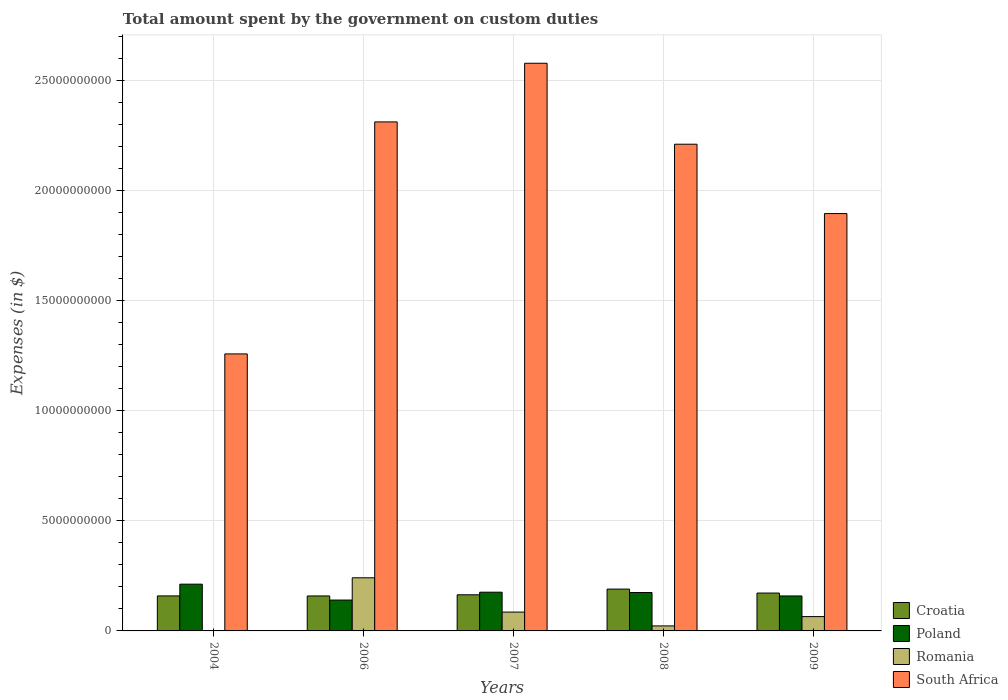How many different coloured bars are there?
Keep it short and to the point. 4. How many groups of bars are there?
Give a very brief answer. 5. Are the number of bars per tick equal to the number of legend labels?
Make the answer very short. Yes. Are the number of bars on each tick of the X-axis equal?
Give a very brief answer. Yes. How many bars are there on the 1st tick from the left?
Make the answer very short. 4. How many bars are there on the 2nd tick from the right?
Provide a short and direct response. 4. What is the amount spent on custom duties by the government in Poland in 2008?
Your answer should be compact. 1.74e+09. Across all years, what is the maximum amount spent on custom duties by the government in South Africa?
Give a very brief answer. 2.58e+1. Across all years, what is the minimum amount spent on custom duties by the government in Romania?
Provide a succinct answer. 7.91e+06. What is the total amount spent on custom duties by the government in Romania in the graph?
Your answer should be very brief. 4.16e+09. What is the difference between the amount spent on custom duties by the government in Romania in 2007 and that in 2009?
Provide a succinct answer. 2.05e+08. What is the difference between the amount spent on custom duties by the government in Romania in 2008 and the amount spent on custom duties by the government in Croatia in 2009?
Provide a succinct answer. -1.49e+09. What is the average amount spent on custom duties by the government in South Africa per year?
Keep it short and to the point. 2.05e+1. In the year 2006, what is the difference between the amount spent on custom duties by the government in Romania and amount spent on custom duties by the government in Croatia?
Make the answer very short. 8.26e+08. What is the ratio of the amount spent on custom duties by the government in South Africa in 2008 to that in 2009?
Offer a terse response. 1.17. What is the difference between the highest and the second highest amount spent on custom duties by the government in Poland?
Keep it short and to the point. 3.65e+08. What is the difference between the highest and the lowest amount spent on custom duties by the government in Poland?
Provide a succinct answer. 7.22e+08. In how many years, is the amount spent on custom duties by the government in Croatia greater than the average amount spent on custom duties by the government in Croatia taken over all years?
Provide a short and direct response. 2. Is the sum of the amount spent on custom duties by the government in Romania in 2006 and 2007 greater than the maximum amount spent on custom duties by the government in South Africa across all years?
Keep it short and to the point. No. Is it the case that in every year, the sum of the amount spent on custom duties by the government in Croatia and amount spent on custom duties by the government in South Africa is greater than the sum of amount spent on custom duties by the government in Poland and amount spent on custom duties by the government in Romania?
Provide a short and direct response. Yes. What does the 3rd bar from the left in 2009 represents?
Provide a short and direct response. Romania. What does the 3rd bar from the right in 2004 represents?
Offer a terse response. Poland. Is it the case that in every year, the sum of the amount spent on custom duties by the government in Romania and amount spent on custom duties by the government in Croatia is greater than the amount spent on custom duties by the government in South Africa?
Provide a short and direct response. No. How many bars are there?
Your response must be concise. 20. Are all the bars in the graph horizontal?
Make the answer very short. No. What is the difference between two consecutive major ticks on the Y-axis?
Your answer should be very brief. 5.00e+09. Does the graph contain any zero values?
Provide a short and direct response. No. Where does the legend appear in the graph?
Offer a terse response. Bottom right. How many legend labels are there?
Offer a terse response. 4. How are the legend labels stacked?
Keep it short and to the point. Vertical. What is the title of the graph?
Provide a short and direct response. Total amount spent by the government on custom duties. What is the label or title of the X-axis?
Offer a terse response. Years. What is the label or title of the Y-axis?
Keep it short and to the point. Expenses (in $). What is the Expenses (in $) in Croatia in 2004?
Your response must be concise. 1.59e+09. What is the Expenses (in $) of Poland in 2004?
Give a very brief answer. 2.12e+09. What is the Expenses (in $) in Romania in 2004?
Ensure brevity in your answer.  7.91e+06. What is the Expenses (in $) in South Africa in 2004?
Your answer should be very brief. 1.26e+1. What is the Expenses (in $) of Croatia in 2006?
Offer a terse response. 1.59e+09. What is the Expenses (in $) of Poland in 2006?
Your answer should be compact. 1.40e+09. What is the Expenses (in $) of Romania in 2006?
Ensure brevity in your answer.  2.41e+09. What is the Expenses (in $) in South Africa in 2006?
Keep it short and to the point. 2.31e+1. What is the Expenses (in $) of Croatia in 2007?
Keep it short and to the point. 1.64e+09. What is the Expenses (in $) of Poland in 2007?
Offer a very short reply. 1.76e+09. What is the Expenses (in $) in Romania in 2007?
Keep it short and to the point. 8.56e+08. What is the Expenses (in $) of South Africa in 2007?
Provide a short and direct response. 2.58e+1. What is the Expenses (in $) in Croatia in 2008?
Your response must be concise. 1.90e+09. What is the Expenses (in $) in Poland in 2008?
Make the answer very short. 1.74e+09. What is the Expenses (in $) in Romania in 2008?
Give a very brief answer. 2.28e+08. What is the Expenses (in $) in South Africa in 2008?
Make the answer very short. 2.21e+1. What is the Expenses (in $) of Croatia in 2009?
Provide a succinct answer. 1.72e+09. What is the Expenses (in $) in Poland in 2009?
Provide a short and direct response. 1.59e+09. What is the Expenses (in $) in Romania in 2009?
Your answer should be compact. 6.50e+08. What is the Expenses (in $) in South Africa in 2009?
Provide a succinct answer. 1.90e+1. Across all years, what is the maximum Expenses (in $) of Croatia?
Make the answer very short. 1.90e+09. Across all years, what is the maximum Expenses (in $) in Poland?
Provide a short and direct response. 2.12e+09. Across all years, what is the maximum Expenses (in $) of Romania?
Provide a short and direct response. 2.41e+09. Across all years, what is the maximum Expenses (in $) of South Africa?
Your response must be concise. 2.58e+1. Across all years, what is the minimum Expenses (in $) of Croatia?
Your answer should be very brief. 1.59e+09. Across all years, what is the minimum Expenses (in $) of Poland?
Your answer should be very brief. 1.40e+09. Across all years, what is the minimum Expenses (in $) of Romania?
Your response must be concise. 7.91e+06. Across all years, what is the minimum Expenses (in $) in South Africa?
Your answer should be very brief. 1.26e+1. What is the total Expenses (in $) of Croatia in the graph?
Your answer should be very brief. 8.44e+09. What is the total Expenses (in $) of Poland in the graph?
Ensure brevity in your answer.  8.62e+09. What is the total Expenses (in $) of Romania in the graph?
Give a very brief answer. 4.16e+09. What is the total Expenses (in $) in South Africa in the graph?
Keep it short and to the point. 1.03e+11. What is the difference between the Expenses (in $) of Croatia in 2004 and that in 2006?
Your answer should be very brief. 1.70e+06. What is the difference between the Expenses (in $) in Poland in 2004 and that in 2006?
Your response must be concise. 7.22e+08. What is the difference between the Expenses (in $) of Romania in 2004 and that in 2006?
Provide a short and direct response. -2.41e+09. What is the difference between the Expenses (in $) of South Africa in 2004 and that in 2006?
Your response must be concise. -1.05e+1. What is the difference between the Expenses (in $) in Croatia in 2004 and that in 2007?
Make the answer very short. -5.13e+07. What is the difference between the Expenses (in $) of Poland in 2004 and that in 2007?
Your answer should be compact. 3.65e+08. What is the difference between the Expenses (in $) of Romania in 2004 and that in 2007?
Offer a very short reply. -8.48e+08. What is the difference between the Expenses (in $) in South Africa in 2004 and that in 2007?
Keep it short and to the point. -1.32e+1. What is the difference between the Expenses (in $) in Croatia in 2004 and that in 2008?
Provide a short and direct response. -3.10e+08. What is the difference between the Expenses (in $) of Poland in 2004 and that in 2008?
Your answer should be very brief. 3.80e+08. What is the difference between the Expenses (in $) of Romania in 2004 and that in 2008?
Your answer should be compact. -2.20e+08. What is the difference between the Expenses (in $) in South Africa in 2004 and that in 2008?
Give a very brief answer. -9.53e+09. What is the difference between the Expenses (in $) of Croatia in 2004 and that in 2009?
Keep it short and to the point. -1.30e+08. What is the difference between the Expenses (in $) in Poland in 2004 and that in 2009?
Give a very brief answer. 5.36e+08. What is the difference between the Expenses (in $) in Romania in 2004 and that in 2009?
Your answer should be very brief. -6.43e+08. What is the difference between the Expenses (in $) in South Africa in 2004 and that in 2009?
Keep it short and to the point. -6.38e+09. What is the difference between the Expenses (in $) in Croatia in 2006 and that in 2007?
Provide a short and direct response. -5.30e+07. What is the difference between the Expenses (in $) of Poland in 2006 and that in 2007?
Offer a very short reply. -3.57e+08. What is the difference between the Expenses (in $) of Romania in 2006 and that in 2007?
Keep it short and to the point. 1.56e+09. What is the difference between the Expenses (in $) of South Africa in 2006 and that in 2007?
Provide a succinct answer. -2.67e+09. What is the difference between the Expenses (in $) of Croatia in 2006 and that in 2008?
Keep it short and to the point. -3.12e+08. What is the difference between the Expenses (in $) in Poland in 2006 and that in 2008?
Offer a very short reply. -3.42e+08. What is the difference between the Expenses (in $) of Romania in 2006 and that in 2008?
Offer a terse response. 2.19e+09. What is the difference between the Expenses (in $) of South Africa in 2006 and that in 2008?
Give a very brief answer. 1.01e+09. What is the difference between the Expenses (in $) in Croatia in 2006 and that in 2009?
Your answer should be compact. -1.32e+08. What is the difference between the Expenses (in $) in Poland in 2006 and that in 2009?
Your answer should be very brief. -1.86e+08. What is the difference between the Expenses (in $) in Romania in 2006 and that in 2009?
Your answer should be compact. 1.76e+09. What is the difference between the Expenses (in $) in South Africa in 2006 and that in 2009?
Your response must be concise. 4.16e+09. What is the difference between the Expenses (in $) of Croatia in 2007 and that in 2008?
Offer a very short reply. -2.59e+08. What is the difference between the Expenses (in $) in Poland in 2007 and that in 2008?
Your answer should be very brief. 1.50e+07. What is the difference between the Expenses (in $) of Romania in 2007 and that in 2008?
Keep it short and to the point. 6.28e+08. What is the difference between the Expenses (in $) in South Africa in 2007 and that in 2008?
Provide a short and direct response. 3.68e+09. What is the difference between the Expenses (in $) in Croatia in 2007 and that in 2009?
Your response must be concise. -7.92e+07. What is the difference between the Expenses (in $) of Poland in 2007 and that in 2009?
Provide a succinct answer. 1.71e+08. What is the difference between the Expenses (in $) in Romania in 2007 and that in 2009?
Offer a terse response. 2.05e+08. What is the difference between the Expenses (in $) of South Africa in 2007 and that in 2009?
Offer a terse response. 6.83e+09. What is the difference between the Expenses (in $) of Croatia in 2008 and that in 2009?
Your answer should be very brief. 1.80e+08. What is the difference between the Expenses (in $) of Poland in 2008 and that in 2009?
Offer a very short reply. 1.56e+08. What is the difference between the Expenses (in $) in Romania in 2008 and that in 2009?
Your response must be concise. -4.23e+08. What is the difference between the Expenses (in $) of South Africa in 2008 and that in 2009?
Offer a terse response. 3.15e+09. What is the difference between the Expenses (in $) of Croatia in 2004 and the Expenses (in $) of Poland in 2006?
Make the answer very short. 1.88e+08. What is the difference between the Expenses (in $) in Croatia in 2004 and the Expenses (in $) in Romania in 2006?
Provide a succinct answer. -8.24e+08. What is the difference between the Expenses (in $) of Croatia in 2004 and the Expenses (in $) of South Africa in 2006?
Ensure brevity in your answer.  -2.15e+1. What is the difference between the Expenses (in $) of Poland in 2004 and the Expenses (in $) of Romania in 2006?
Your response must be concise. -2.90e+08. What is the difference between the Expenses (in $) in Poland in 2004 and the Expenses (in $) in South Africa in 2006?
Ensure brevity in your answer.  -2.10e+1. What is the difference between the Expenses (in $) of Romania in 2004 and the Expenses (in $) of South Africa in 2006?
Offer a very short reply. -2.31e+1. What is the difference between the Expenses (in $) of Croatia in 2004 and the Expenses (in $) of Poland in 2007?
Your answer should be very brief. -1.69e+08. What is the difference between the Expenses (in $) in Croatia in 2004 and the Expenses (in $) in Romania in 2007?
Offer a very short reply. 7.35e+08. What is the difference between the Expenses (in $) in Croatia in 2004 and the Expenses (in $) in South Africa in 2007?
Your answer should be compact. -2.42e+1. What is the difference between the Expenses (in $) of Poland in 2004 and the Expenses (in $) of Romania in 2007?
Make the answer very short. 1.27e+09. What is the difference between the Expenses (in $) in Poland in 2004 and the Expenses (in $) in South Africa in 2007?
Keep it short and to the point. -2.37e+1. What is the difference between the Expenses (in $) in Romania in 2004 and the Expenses (in $) in South Africa in 2007?
Make the answer very short. -2.58e+1. What is the difference between the Expenses (in $) in Croatia in 2004 and the Expenses (in $) in Poland in 2008?
Ensure brevity in your answer.  -1.54e+08. What is the difference between the Expenses (in $) of Croatia in 2004 and the Expenses (in $) of Romania in 2008?
Offer a very short reply. 1.36e+09. What is the difference between the Expenses (in $) of Croatia in 2004 and the Expenses (in $) of South Africa in 2008?
Your answer should be compact. -2.05e+1. What is the difference between the Expenses (in $) in Poland in 2004 and the Expenses (in $) in Romania in 2008?
Give a very brief answer. 1.90e+09. What is the difference between the Expenses (in $) in Poland in 2004 and the Expenses (in $) in South Africa in 2008?
Make the answer very short. -2.00e+1. What is the difference between the Expenses (in $) in Romania in 2004 and the Expenses (in $) in South Africa in 2008?
Offer a very short reply. -2.21e+1. What is the difference between the Expenses (in $) in Croatia in 2004 and the Expenses (in $) in Poland in 2009?
Provide a succinct answer. 1.70e+06. What is the difference between the Expenses (in $) in Croatia in 2004 and the Expenses (in $) in Romania in 2009?
Give a very brief answer. 9.40e+08. What is the difference between the Expenses (in $) in Croatia in 2004 and the Expenses (in $) in South Africa in 2009?
Give a very brief answer. -1.74e+1. What is the difference between the Expenses (in $) of Poland in 2004 and the Expenses (in $) of Romania in 2009?
Ensure brevity in your answer.  1.47e+09. What is the difference between the Expenses (in $) in Poland in 2004 and the Expenses (in $) in South Africa in 2009?
Your answer should be compact. -1.68e+1. What is the difference between the Expenses (in $) in Romania in 2004 and the Expenses (in $) in South Africa in 2009?
Offer a very short reply. -1.90e+1. What is the difference between the Expenses (in $) of Croatia in 2006 and the Expenses (in $) of Poland in 2007?
Provide a short and direct response. -1.71e+08. What is the difference between the Expenses (in $) in Croatia in 2006 and the Expenses (in $) in Romania in 2007?
Make the answer very short. 7.33e+08. What is the difference between the Expenses (in $) of Croatia in 2006 and the Expenses (in $) of South Africa in 2007?
Your answer should be compact. -2.42e+1. What is the difference between the Expenses (in $) in Poland in 2006 and the Expenses (in $) in Romania in 2007?
Your answer should be compact. 5.47e+08. What is the difference between the Expenses (in $) of Poland in 2006 and the Expenses (in $) of South Africa in 2007?
Your answer should be very brief. -2.44e+1. What is the difference between the Expenses (in $) of Romania in 2006 and the Expenses (in $) of South Africa in 2007?
Offer a very short reply. -2.34e+1. What is the difference between the Expenses (in $) of Croatia in 2006 and the Expenses (in $) of Poland in 2008?
Offer a terse response. -1.56e+08. What is the difference between the Expenses (in $) in Croatia in 2006 and the Expenses (in $) in Romania in 2008?
Provide a succinct answer. 1.36e+09. What is the difference between the Expenses (in $) of Croatia in 2006 and the Expenses (in $) of South Africa in 2008?
Make the answer very short. -2.05e+1. What is the difference between the Expenses (in $) in Poland in 2006 and the Expenses (in $) in Romania in 2008?
Provide a succinct answer. 1.18e+09. What is the difference between the Expenses (in $) in Poland in 2006 and the Expenses (in $) in South Africa in 2008?
Offer a terse response. -2.07e+1. What is the difference between the Expenses (in $) of Romania in 2006 and the Expenses (in $) of South Africa in 2008?
Your answer should be compact. -1.97e+1. What is the difference between the Expenses (in $) of Croatia in 2006 and the Expenses (in $) of Romania in 2009?
Your response must be concise. 9.39e+08. What is the difference between the Expenses (in $) in Croatia in 2006 and the Expenses (in $) in South Africa in 2009?
Give a very brief answer. -1.74e+1. What is the difference between the Expenses (in $) in Poland in 2006 and the Expenses (in $) in Romania in 2009?
Make the answer very short. 7.53e+08. What is the difference between the Expenses (in $) of Poland in 2006 and the Expenses (in $) of South Africa in 2009?
Give a very brief answer. -1.76e+1. What is the difference between the Expenses (in $) in Romania in 2006 and the Expenses (in $) in South Africa in 2009?
Your answer should be compact. -1.66e+1. What is the difference between the Expenses (in $) of Croatia in 2007 and the Expenses (in $) of Poland in 2008?
Provide a short and direct response. -1.03e+08. What is the difference between the Expenses (in $) of Croatia in 2007 and the Expenses (in $) of Romania in 2008?
Keep it short and to the point. 1.41e+09. What is the difference between the Expenses (in $) in Croatia in 2007 and the Expenses (in $) in South Africa in 2008?
Make the answer very short. -2.05e+1. What is the difference between the Expenses (in $) in Poland in 2007 and the Expenses (in $) in Romania in 2008?
Give a very brief answer. 1.53e+09. What is the difference between the Expenses (in $) of Poland in 2007 and the Expenses (in $) of South Africa in 2008?
Ensure brevity in your answer.  -2.04e+1. What is the difference between the Expenses (in $) of Romania in 2007 and the Expenses (in $) of South Africa in 2008?
Keep it short and to the point. -2.13e+1. What is the difference between the Expenses (in $) of Croatia in 2007 and the Expenses (in $) of Poland in 2009?
Provide a succinct answer. 5.30e+07. What is the difference between the Expenses (in $) in Croatia in 2007 and the Expenses (in $) in Romania in 2009?
Keep it short and to the point. 9.92e+08. What is the difference between the Expenses (in $) in Croatia in 2007 and the Expenses (in $) in South Africa in 2009?
Your response must be concise. -1.73e+1. What is the difference between the Expenses (in $) in Poland in 2007 and the Expenses (in $) in Romania in 2009?
Your response must be concise. 1.11e+09. What is the difference between the Expenses (in $) of Poland in 2007 and the Expenses (in $) of South Africa in 2009?
Your response must be concise. -1.72e+1. What is the difference between the Expenses (in $) in Romania in 2007 and the Expenses (in $) in South Africa in 2009?
Give a very brief answer. -1.81e+1. What is the difference between the Expenses (in $) in Croatia in 2008 and the Expenses (in $) in Poland in 2009?
Provide a succinct answer. 3.12e+08. What is the difference between the Expenses (in $) in Croatia in 2008 and the Expenses (in $) in Romania in 2009?
Provide a succinct answer. 1.25e+09. What is the difference between the Expenses (in $) of Croatia in 2008 and the Expenses (in $) of South Africa in 2009?
Your answer should be compact. -1.71e+1. What is the difference between the Expenses (in $) in Poland in 2008 and the Expenses (in $) in Romania in 2009?
Ensure brevity in your answer.  1.09e+09. What is the difference between the Expenses (in $) of Poland in 2008 and the Expenses (in $) of South Africa in 2009?
Make the answer very short. -1.72e+1. What is the difference between the Expenses (in $) of Romania in 2008 and the Expenses (in $) of South Africa in 2009?
Your answer should be compact. -1.87e+1. What is the average Expenses (in $) in Croatia per year?
Provide a short and direct response. 1.69e+09. What is the average Expenses (in $) in Poland per year?
Ensure brevity in your answer.  1.72e+09. What is the average Expenses (in $) in Romania per year?
Give a very brief answer. 8.31e+08. What is the average Expenses (in $) of South Africa per year?
Provide a short and direct response. 2.05e+1. In the year 2004, what is the difference between the Expenses (in $) in Croatia and Expenses (in $) in Poland?
Provide a short and direct response. -5.34e+08. In the year 2004, what is the difference between the Expenses (in $) of Croatia and Expenses (in $) of Romania?
Your answer should be very brief. 1.58e+09. In the year 2004, what is the difference between the Expenses (in $) of Croatia and Expenses (in $) of South Africa?
Your answer should be compact. -1.10e+1. In the year 2004, what is the difference between the Expenses (in $) of Poland and Expenses (in $) of Romania?
Offer a terse response. 2.12e+09. In the year 2004, what is the difference between the Expenses (in $) in Poland and Expenses (in $) in South Africa?
Make the answer very short. -1.05e+1. In the year 2004, what is the difference between the Expenses (in $) in Romania and Expenses (in $) in South Africa?
Your response must be concise. -1.26e+1. In the year 2006, what is the difference between the Expenses (in $) in Croatia and Expenses (in $) in Poland?
Make the answer very short. 1.86e+08. In the year 2006, what is the difference between the Expenses (in $) in Croatia and Expenses (in $) in Romania?
Ensure brevity in your answer.  -8.26e+08. In the year 2006, what is the difference between the Expenses (in $) in Croatia and Expenses (in $) in South Africa?
Provide a short and direct response. -2.15e+1. In the year 2006, what is the difference between the Expenses (in $) in Poland and Expenses (in $) in Romania?
Your answer should be compact. -1.01e+09. In the year 2006, what is the difference between the Expenses (in $) of Poland and Expenses (in $) of South Africa?
Make the answer very short. -2.17e+1. In the year 2006, what is the difference between the Expenses (in $) of Romania and Expenses (in $) of South Africa?
Give a very brief answer. -2.07e+1. In the year 2007, what is the difference between the Expenses (in $) in Croatia and Expenses (in $) in Poland?
Give a very brief answer. -1.18e+08. In the year 2007, what is the difference between the Expenses (in $) of Croatia and Expenses (in $) of Romania?
Your answer should be very brief. 7.86e+08. In the year 2007, what is the difference between the Expenses (in $) of Croatia and Expenses (in $) of South Africa?
Offer a very short reply. -2.42e+1. In the year 2007, what is the difference between the Expenses (in $) of Poland and Expenses (in $) of Romania?
Keep it short and to the point. 9.04e+08. In the year 2007, what is the difference between the Expenses (in $) of Poland and Expenses (in $) of South Africa?
Provide a succinct answer. -2.40e+1. In the year 2007, what is the difference between the Expenses (in $) of Romania and Expenses (in $) of South Africa?
Give a very brief answer. -2.49e+1. In the year 2008, what is the difference between the Expenses (in $) of Croatia and Expenses (in $) of Poland?
Make the answer very short. 1.56e+08. In the year 2008, what is the difference between the Expenses (in $) of Croatia and Expenses (in $) of Romania?
Your answer should be compact. 1.67e+09. In the year 2008, what is the difference between the Expenses (in $) in Croatia and Expenses (in $) in South Africa?
Give a very brief answer. -2.02e+1. In the year 2008, what is the difference between the Expenses (in $) in Poland and Expenses (in $) in Romania?
Ensure brevity in your answer.  1.52e+09. In the year 2008, what is the difference between the Expenses (in $) in Poland and Expenses (in $) in South Africa?
Your answer should be very brief. -2.04e+1. In the year 2008, what is the difference between the Expenses (in $) in Romania and Expenses (in $) in South Africa?
Your answer should be compact. -2.19e+1. In the year 2009, what is the difference between the Expenses (in $) of Croatia and Expenses (in $) of Poland?
Offer a terse response. 1.32e+08. In the year 2009, what is the difference between the Expenses (in $) of Croatia and Expenses (in $) of Romania?
Your response must be concise. 1.07e+09. In the year 2009, what is the difference between the Expenses (in $) of Croatia and Expenses (in $) of South Africa?
Make the answer very short. -1.72e+1. In the year 2009, what is the difference between the Expenses (in $) in Poland and Expenses (in $) in Romania?
Offer a terse response. 9.39e+08. In the year 2009, what is the difference between the Expenses (in $) in Poland and Expenses (in $) in South Africa?
Your answer should be very brief. -1.74e+1. In the year 2009, what is the difference between the Expenses (in $) in Romania and Expenses (in $) in South Africa?
Provide a succinct answer. -1.83e+1. What is the ratio of the Expenses (in $) of Croatia in 2004 to that in 2006?
Your answer should be very brief. 1. What is the ratio of the Expenses (in $) of Poland in 2004 to that in 2006?
Your answer should be compact. 1.51. What is the ratio of the Expenses (in $) in Romania in 2004 to that in 2006?
Your response must be concise. 0. What is the ratio of the Expenses (in $) of South Africa in 2004 to that in 2006?
Ensure brevity in your answer.  0.54. What is the ratio of the Expenses (in $) in Croatia in 2004 to that in 2007?
Your answer should be compact. 0.97. What is the ratio of the Expenses (in $) of Poland in 2004 to that in 2007?
Provide a short and direct response. 1.21. What is the ratio of the Expenses (in $) in Romania in 2004 to that in 2007?
Offer a very short reply. 0.01. What is the ratio of the Expenses (in $) of South Africa in 2004 to that in 2007?
Ensure brevity in your answer.  0.49. What is the ratio of the Expenses (in $) in Croatia in 2004 to that in 2008?
Provide a short and direct response. 0.84. What is the ratio of the Expenses (in $) in Poland in 2004 to that in 2008?
Your response must be concise. 1.22. What is the ratio of the Expenses (in $) of Romania in 2004 to that in 2008?
Offer a very short reply. 0.03. What is the ratio of the Expenses (in $) of South Africa in 2004 to that in 2008?
Your answer should be compact. 0.57. What is the ratio of the Expenses (in $) of Croatia in 2004 to that in 2009?
Provide a succinct answer. 0.92. What is the ratio of the Expenses (in $) in Poland in 2004 to that in 2009?
Give a very brief answer. 1.34. What is the ratio of the Expenses (in $) of Romania in 2004 to that in 2009?
Give a very brief answer. 0.01. What is the ratio of the Expenses (in $) of South Africa in 2004 to that in 2009?
Make the answer very short. 0.66. What is the ratio of the Expenses (in $) in Poland in 2006 to that in 2007?
Your answer should be very brief. 0.8. What is the ratio of the Expenses (in $) in Romania in 2006 to that in 2007?
Offer a very short reply. 2.82. What is the ratio of the Expenses (in $) in South Africa in 2006 to that in 2007?
Provide a short and direct response. 0.9. What is the ratio of the Expenses (in $) of Croatia in 2006 to that in 2008?
Give a very brief answer. 0.84. What is the ratio of the Expenses (in $) in Poland in 2006 to that in 2008?
Provide a succinct answer. 0.8. What is the ratio of the Expenses (in $) in Romania in 2006 to that in 2008?
Your answer should be compact. 10.6. What is the ratio of the Expenses (in $) of South Africa in 2006 to that in 2008?
Your answer should be compact. 1.05. What is the ratio of the Expenses (in $) of Croatia in 2006 to that in 2009?
Provide a succinct answer. 0.92. What is the ratio of the Expenses (in $) in Poland in 2006 to that in 2009?
Give a very brief answer. 0.88. What is the ratio of the Expenses (in $) in Romania in 2006 to that in 2009?
Keep it short and to the point. 3.71. What is the ratio of the Expenses (in $) in South Africa in 2006 to that in 2009?
Provide a succinct answer. 1.22. What is the ratio of the Expenses (in $) in Croatia in 2007 to that in 2008?
Offer a terse response. 0.86. What is the ratio of the Expenses (in $) of Poland in 2007 to that in 2008?
Ensure brevity in your answer.  1.01. What is the ratio of the Expenses (in $) in Romania in 2007 to that in 2008?
Give a very brief answer. 3.76. What is the ratio of the Expenses (in $) of South Africa in 2007 to that in 2008?
Your answer should be compact. 1.17. What is the ratio of the Expenses (in $) in Croatia in 2007 to that in 2009?
Provide a succinct answer. 0.95. What is the ratio of the Expenses (in $) in Poland in 2007 to that in 2009?
Give a very brief answer. 1.11. What is the ratio of the Expenses (in $) in Romania in 2007 to that in 2009?
Provide a succinct answer. 1.32. What is the ratio of the Expenses (in $) of South Africa in 2007 to that in 2009?
Provide a short and direct response. 1.36. What is the ratio of the Expenses (in $) of Croatia in 2008 to that in 2009?
Ensure brevity in your answer.  1.1. What is the ratio of the Expenses (in $) of Poland in 2008 to that in 2009?
Provide a succinct answer. 1.1. What is the ratio of the Expenses (in $) in Romania in 2008 to that in 2009?
Your answer should be compact. 0.35. What is the ratio of the Expenses (in $) of South Africa in 2008 to that in 2009?
Give a very brief answer. 1.17. What is the difference between the highest and the second highest Expenses (in $) in Croatia?
Make the answer very short. 1.80e+08. What is the difference between the highest and the second highest Expenses (in $) in Poland?
Provide a short and direct response. 3.65e+08. What is the difference between the highest and the second highest Expenses (in $) in Romania?
Your answer should be compact. 1.56e+09. What is the difference between the highest and the second highest Expenses (in $) in South Africa?
Your answer should be very brief. 2.67e+09. What is the difference between the highest and the lowest Expenses (in $) in Croatia?
Make the answer very short. 3.12e+08. What is the difference between the highest and the lowest Expenses (in $) of Poland?
Make the answer very short. 7.22e+08. What is the difference between the highest and the lowest Expenses (in $) in Romania?
Offer a very short reply. 2.41e+09. What is the difference between the highest and the lowest Expenses (in $) in South Africa?
Provide a short and direct response. 1.32e+1. 